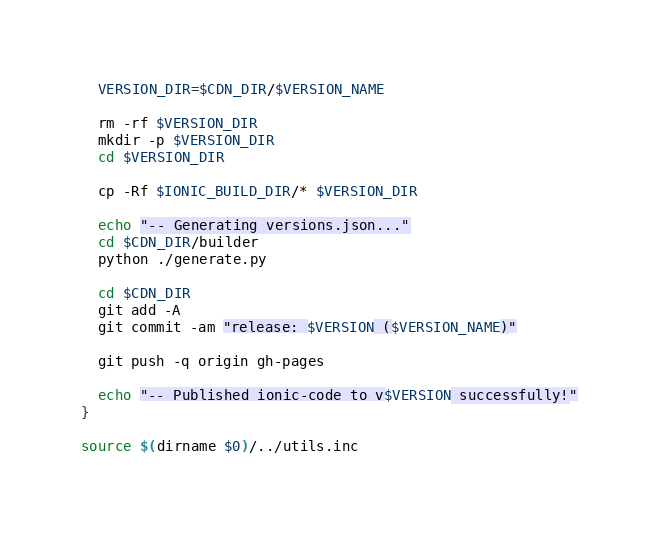Convert code to text. <code><loc_0><loc_0><loc_500><loc_500><_Bash_>
  VERSION_DIR=$CDN_DIR/$VERSION_NAME

  rm -rf $VERSION_DIR
  mkdir -p $VERSION_DIR
  cd $VERSION_DIR

  cp -Rf $IONIC_BUILD_DIR/* $VERSION_DIR

  echo "-- Generating versions.json..."
  cd $CDN_DIR/builder
  python ./generate.py

  cd $CDN_DIR
  git add -A
  git commit -am "release: $VERSION ($VERSION_NAME)"

  git push -q origin gh-pages

  echo "-- Published ionic-code to v$VERSION successfully!"
}

source $(dirname $0)/../utils.inc
</code> 